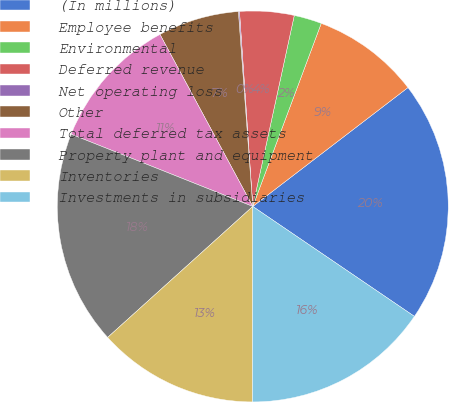Convert chart to OTSL. <chart><loc_0><loc_0><loc_500><loc_500><pie_chart><fcel>(In millions)<fcel>Employee benefits<fcel>Environmental<fcel>Deferred revenue<fcel>Net operating loss<fcel>Other<fcel>Total deferred tax assets<fcel>Property plant and equipment<fcel>Inventories<fcel>Investments in subsidiaries<nl><fcel>19.91%<fcel>8.9%<fcel>2.29%<fcel>4.49%<fcel>0.09%<fcel>6.7%<fcel>11.1%<fcel>17.71%<fcel>13.3%<fcel>15.51%<nl></chart> 